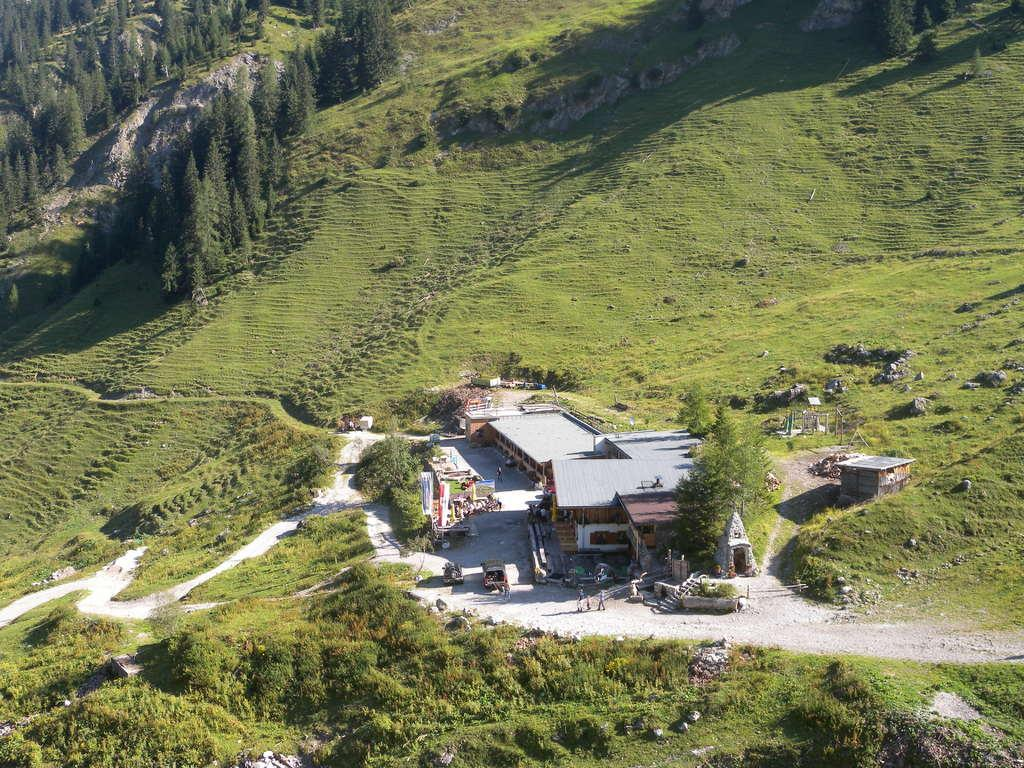What type of structures can be seen in the image? There are houses in the image. What type of vegetation is present in the image? There are trees in the image. What type of ground cover is visible in the image? There is grass visible in the image. How many cats can be seen giving birth to a cow in the image? There are no cats or cows present in the image, and therefore no such event is taking place. 